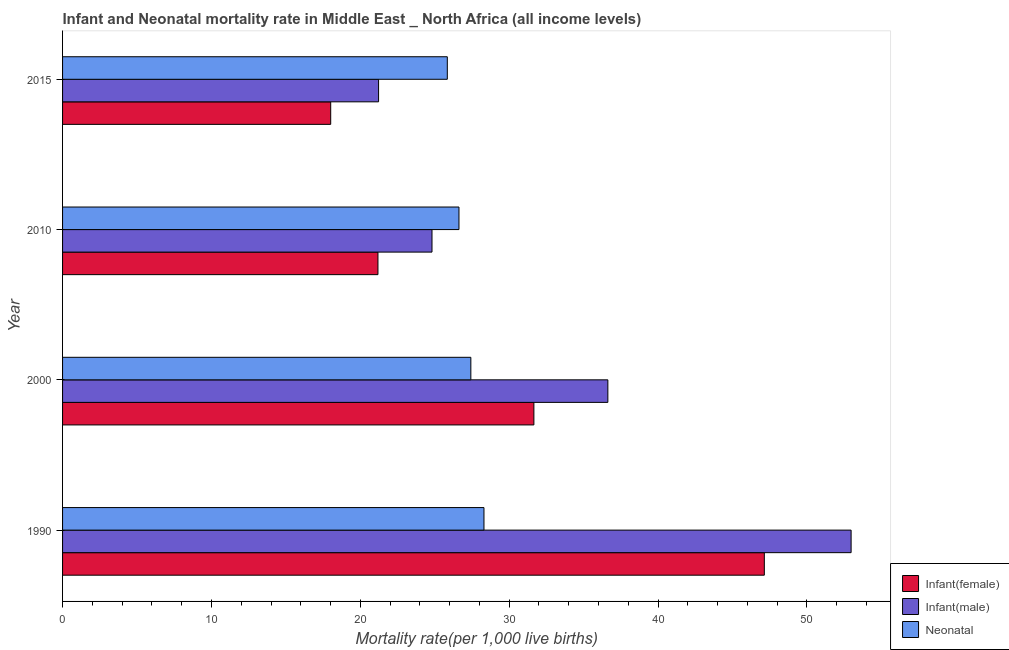How many different coloured bars are there?
Ensure brevity in your answer.  3. Are the number of bars per tick equal to the number of legend labels?
Give a very brief answer. Yes. How many bars are there on the 1st tick from the top?
Your response must be concise. 3. How many bars are there on the 3rd tick from the bottom?
Your response must be concise. 3. What is the label of the 1st group of bars from the top?
Provide a short and direct response. 2015. In how many cases, is the number of bars for a given year not equal to the number of legend labels?
Provide a succinct answer. 0. What is the infant mortality rate(female) in 2010?
Ensure brevity in your answer.  21.18. Across all years, what is the maximum infant mortality rate(male)?
Provide a short and direct response. 52.97. Across all years, what is the minimum infant mortality rate(male)?
Offer a very short reply. 21.23. In which year was the infant mortality rate(female) maximum?
Your answer should be very brief. 1990. In which year was the neonatal mortality rate minimum?
Make the answer very short. 2015. What is the total neonatal mortality rate in the graph?
Offer a very short reply. 108.2. What is the difference between the neonatal mortality rate in 1990 and that in 2015?
Keep it short and to the point. 2.46. What is the difference between the infant mortality rate(male) in 2000 and the infant mortality rate(female) in 2015?
Provide a short and direct response. 18.62. What is the average infant mortality rate(male) per year?
Your response must be concise. 33.91. In the year 1990, what is the difference between the neonatal mortality rate and infant mortality rate(female)?
Make the answer very short. -18.83. In how many years, is the infant mortality rate(female) greater than 10 ?
Offer a very short reply. 4. What is the ratio of the infant mortality rate(female) in 2010 to that in 2015?
Provide a succinct answer. 1.18. Is the difference between the neonatal mortality rate in 1990 and 2000 greater than the difference between the infant mortality rate(male) in 1990 and 2000?
Offer a very short reply. No. What is the difference between the highest and the second highest neonatal mortality rate?
Provide a short and direct response. 0.88. What is the difference between the highest and the lowest neonatal mortality rate?
Your answer should be compact. 2.46. In how many years, is the neonatal mortality rate greater than the average neonatal mortality rate taken over all years?
Your answer should be very brief. 2. What does the 2nd bar from the top in 2000 represents?
Your answer should be compact. Infant(male). What does the 3rd bar from the bottom in 2015 represents?
Provide a short and direct response. Neonatal . Is it the case that in every year, the sum of the infant mortality rate(female) and infant mortality rate(male) is greater than the neonatal mortality rate?
Offer a terse response. Yes. How many bars are there?
Offer a very short reply. 12. Does the graph contain any zero values?
Your response must be concise. No. What is the title of the graph?
Your response must be concise. Infant and Neonatal mortality rate in Middle East _ North Africa (all income levels). What is the label or title of the X-axis?
Your response must be concise. Mortality rate(per 1,0 live births). What is the label or title of the Y-axis?
Offer a very short reply. Year. What is the Mortality rate(per 1,000 live births) of Infant(female) in 1990?
Your response must be concise. 47.14. What is the Mortality rate(per 1,000 live births) in Infant(male) in 1990?
Offer a terse response. 52.97. What is the Mortality rate(per 1,000 live births) in Neonatal  in 1990?
Your answer should be compact. 28.31. What is the Mortality rate(per 1,000 live births) of Infant(female) in 2000?
Give a very brief answer. 31.66. What is the Mortality rate(per 1,000 live births) of Infant(male) in 2000?
Your answer should be compact. 36.63. What is the Mortality rate(per 1,000 live births) in Neonatal  in 2000?
Offer a terse response. 27.42. What is the Mortality rate(per 1,000 live births) in Infant(female) in 2010?
Offer a very short reply. 21.18. What is the Mortality rate(per 1,000 live births) of Infant(male) in 2010?
Your answer should be very brief. 24.81. What is the Mortality rate(per 1,000 live births) of Neonatal  in 2010?
Make the answer very short. 26.63. What is the Mortality rate(per 1,000 live births) in Infant(female) in 2015?
Make the answer very short. 18.01. What is the Mortality rate(per 1,000 live births) of Infant(male) in 2015?
Provide a short and direct response. 21.23. What is the Mortality rate(per 1,000 live births) of Neonatal  in 2015?
Provide a succinct answer. 25.84. Across all years, what is the maximum Mortality rate(per 1,000 live births) of Infant(female)?
Keep it short and to the point. 47.14. Across all years, what is the maximum Mortality rate(per 1,000 live births) of Infant(male)?
Give a very brief answer. 52.97. Across all years, what is the maximum Mortality rate(per 1,000 live births) in Neonatal ?
Provide a succinct answer. 28.31. Across all years, what is the minimum Mortality rate(per 1,000 live births) of Infant(female)?
Give a very brief answer. 18.01. Across all years, what is the minimum Mortality rate(per 1,000 live births) of Infant(male)?
Your answer should be very brief. 21.23. Across all years, what is the minimum Mortality rate(per 1,000 live births) in Neonatal ?
Ensure brevity in your answer.  25.84. What is the total Mortality rate(per 1,000 live births) of Infant(female) in the graph?
Provide a short and direct response. 117.99. What is the total Mortality rate(per 1,000 live births) of Infant(male) in the graph?
Keep it short and to the point. 135.63. What is the total Mortality rate(per 1,000 live births) of Neonatal  in the graph?
Provide a succinct answer. 108.2. What is the difference between the Mortality rate(per 1,000 live births) in Infant(female) in 1990 and that in 2000?
Offer a very short reply. 15.48. What is the difference between the Mortality rate(per 1,000 live births) in Infant(male) in 1990 and that in 2000?
Make the answer very short. 16.34. What is the difference between the Mortality rate(per 1,000 live births) in Neonatal  in 1990 and that in 2000?
Give a very brief answer. 0.88. What is the difference between the Mortality rate(per 1,000 live births) of Infant(female) in 1990 and that in 2010?
Provide a succinct answer. 25.95. What is the difference between the Mortality rate(per 1,000 live births) in Infant(male) in 1990 and that in 2010?
Provide a short and direct response. 28.15. What is the difference between the Mortality rate(per 1,000 live births) in Neonatal  in 1990 and that in 2010?
Provide a short and direct response. 1.68. What is the difference between the Mortality rate(per 1,000 live births) of Infant(female) in 1990 and that in 2015?
Your response must be concise. 29.13. What is the difference between the Mortality rate(per 1,000 live births) in Infant(male) in 1990 and that in 2015?
Offer a terse response. 31.74. What is the difference between the Mortality rate(per 1,000 live births) in Neonatal  in 1990 and that in 2015?
Your answer should be compact. 2.46. What is the difference between the Mortality rate(per 1,000 live births) of Infant(female) in 2000 and that in 2010?
Offer a terse response. 10.47. What is the difference between the Mortality rate(per 1,000 live births) in Infant(male) in 2000 and that in 2010?
Your answer should be compact. 11.81. What is the difference between the Mortality rate(per 1,000 live births) of Neonatal  in 2000 and that in 2010?
Offer a terse response. 0.8. What is the difference between the Mortality rate(per 1,000 live births) of Infant(female) in 2000 and that in 2015?
Keep it short and to the point. 13.65. What is the difference between the Mortality rate(per 1,000 live births) in Infant(male) in 2000 and that in 2015?
Ensure brevity in your answer.  15.4. What is the difference between the Mortality rate(per 1,000 live births) of Neonatal  in 2000 and that in 2015?
Offer a terse response. 1.58. What is the difference between the Mortality rate(per 1,000 live births) in Infant(female) in 2010 and that in 2015?
Offer a very short reply. 3.17. What is the difference between the Mortality rate(per 1,000 live births) in Infant(male) in 2010 and that in 2015?
Provide a short and direct response. 3.59. What is the difference between the Mortality rate(per 1,000 live births) of Neonatal  in 2010 and that in 2015?
Offer a terse response. 0.78. What is the difference between the Mortality rate(per 1,000 live births) in Infant(female) in 1990 and the Mortality rate(per 1,000 live births) in Infant(male) in 2000?
Give a very brief answer. 10.51. What is the difference between the Mortality rate(per 1,000 live births) in Infant(female) in 1990 and the Mortality rate(per 1,000 live births) in Neonatal  in 2000?
Ensure brevity in your answer.  19.71. What is the difference between the Mortality rate(per 1,000 live births) of Infant(male) in 1990 and the Mortality rate(per 1,000 live births) of Neonatal  in 2000?
Keep it short and to the point. 25.54. What is the difference between the Mortality rate(per 1,000 live births) of Infant(female) in 1990 and the Mortality rate(per 1,000 live births) of Infant(male) in 2010?
Ensure brevity in your answer.  22.32. What is the difference between the Mortality rate(per 1,000 live births) in Infant(female) in 1990 and the Mortality rate(per 1,000 live births) in Neonatal  in 2010?
Your answer should be very brief. 20.51. What is the difference between the Mortality rate(per 1,000 live births) of Infant(male) in 1990 and the Mortality rate(per 1,000 live births) of Neonatal  in 2010?
Offer a terse response. 26.34. What is the difference between the Mortality rate(per 1,000 live births) in Infant(female) in 1990 and the Mortality rate(per 1,000 live births) in Infant(male) in 2015?
Your response must be concise. 25.91. What is the difference between the Mortality rate(per 1,000 live births) in Infant(female) in 1990 and the Mortality rate(per 1,000 live births) in Neonatal  in 2015?
Give a very brief answer. 21.29. What is the difference between the Mortality rate(per 1,000 live births) of Infant(male) in 1990 and the Mortality rate(per 1,000 live births) of Neonatal  in 2015?
Ensure brevity in your answer.  27.12. What is the difference between the Mortality rate(per 1,000 live births) of Infant(female) in 2000 and the Mortality rate(per 1,000 live births) of Infant(male) in 2010?
Make the answer very short. 6.84. What is the difference between the Mortality rate(per 1,000 live births) of Infant(female) in 2000 and the Mortality rate(per 1,000 live births) of Neonatal  in 2010?
Provide a short and direct response. 5.03. What is the difference between the Mortality rate(per 1,000 live births) in Infant(male) in 2000 and the Mortality rate(per 1,000 live births) in Neonatal  in 2010?
Ensure brevity in your answer.  10. What is the difference between the Mortality rate(per 1,000 live births) of Infant(female) in 2000 and the Mortality rate(per 1,000 live births) of Infant(male) in 2015?
Make the answer very short. 10.43. What is the difference between the Mortality rate(per 1,000 live births) in Infant(female) in 2000 and the Mortality rate(per 1,000 live births) in Neonatal  in 2015?
Offer a terse response. 5.82. What is the difference between the Mortality rate(per 1,000 live births) of Infant(male) in 2000 and the Mortality rate(per 1,000 live births) of Neonatal  in 2015?
Your answer should be very brief. 10.78. What is the difference between the Mortality rate(per 1,000 live births) of Infant(female) in 2010 and the Mortality rate(per 1,000 live births) of Infant(male) in 2015?
Keep it short and to the point. -0.04. What is the difference between the Mortality rate(per 1,000 live births) in Infant(female) in 2010 and the Mortality rate(per 1,000 live births) in Neonatal  in 2015?
Your answer should be compact. -4.66. What is the difference between the Mortality rate(per 1,000 live births) in Infant(male) in 2010 and the Mortality rate(per 1,000 live births) in Neonatal  in 2015?
Your answer should be compact. -1.03. What is the average Mortality rate(per 1,000 live births) in Infant(female) per year?
Make the answer very short. 29.5. What is the average Mortality rate(per 1,000 live births) of Infant(male) per year?
Your answer should be very brief. 33.91. What is the average Mortality rate(per 1,000 live births) in Neonatal  per year?
Keep it short and to the point. 27.05. In the year 1990, what is the difference between the Mortality rate(per 1,000 live births) in Infant(female) and Mortality rate(per 1,000 live births) in Infant(male)?
Your answer should be very brief. -5.83. In the year 1990, what is the difference between the Mortality rate(per 1,000 live births) in Infant(female) and Mortality rate(per 1,000 live births) in Neonatal ?
Your answer should be compact. 18.83. In the year 1990, what is the difference between the Mortality rate(per 1,000 live births) in Infant(male) and Mortality rate(per 1,000 live births) in Neonatal ?
Provide a short and direct response. 24.66. In the year 2000, what is the difference between the Mortality rate(per 1,000 live births) of Infant(female) and Mortality rate(per 1,000 live births) of Infant(male)?
Provide a short and direct response. -4.97. In the year 2000, what is the difference between the Mortality rate(per 1,000 live births) in Infant(female) and Mortality rate(per 1,000 live births) in Neonatal ?
Offer a terse response. 4.24. In the year 2000, what is the difference between the Mortality rate(per 1,000 live births) of Infant(male) and Mortality rate(per 1,000 live births) of Neonatal ?
Your answer should be compact. 9.2. In the year 2010, what is the difference between the Mortality rate(per 1,000 live births) of Infant(female) and Mortality rate(per 1,000 live births) of Infant(male)?
Ensure brevity in your answer.  -3.63. In the year 2010, what is the difference between the Mortality rate(per 1,000 live births) in Infant(female) and Mortality rate(per 1,000 live births) in Neonatal ?
Keep it short and to the point. -5.44. In the year 2010, what is the difference between the Mortality rate(per 1,000 live births) in Infant(male) and Mortality rate(per 1,000 live births) in Neonatal ?
Keep it short and to the point. -1.81. In the year 2015, what is the difference between the Mortality rate(per 1,000 live births) in Infant(female) and Mortality rate(per 1,000 live births) in Infant(male)?
Give a very brief answer. -3.21. In the year 2015, what is the difference between the Mortality rate(per 1,000 live births) of Infant(female) and Mortality rate(per 1,000 live births) of Neonatal ?
Give a very brief answer. -7.83. In the year 2015, what is the difference between the Mortality rate(per 1,000 live births) in Infant(male) and Mortality rate(per 1,000 live births) in Neonatal ?
Offer a terse response. -4.62. What is the ratio of the Mortality rate(per 1,000 live births) in Infant(female) in 1990 to that in 2000?
Provide a succinct answer. 1.49. What is the ratio of the Mortality rate(per 1,000 live births) in Infant(male) in 1990 to that in 2000?
Your answer should be very brief. 1.45. What is the ratio of the Mortality rate(per 1,000 live births) of Neonatal  in 1990 to that in 2000?
Ensure brevity in your answer.  1.03. What is the ratio of the Mortality rate(per 1,000 live births) of Infant(female) in 1990 to that in 2010?
Your answer should be very brief. 2.23. What is the ratio of the Mortality rate(per 1,000 live births) in Infant(male) in 1990 to that in 2010?
Provide a succinct answer. 2.13. What is the ratio of the Mortality rate(per 1,000 live births) in Neonatal  in 1990 to that in 2010?
Provide a short and direct response. 1.06. What is the ratio of the Mortality rate(per 1,000 live births) in Infant(female) in 1990 to that in 2015?
Make the answer very short. 2.62. What is the ratio of the Mortality rate(per 1,000 live births) of Infant(male) in 1990 to that in 2015?
Keep it short and to the point. 2.5. What is the ratio of the Mortality rate(per 1,000 live births) of Neonatal  in 1990 to that in 2015?
Provide a short and direct response. 1.1. What is the ratio of the Mortality rate(per 1,000 live births) of Infant(female) in 2000 to that in 2010?
Your answer should be compact. 1.49. What is the ratio of the Mortality rate(per 1,000 live births) in Infant(male) in 2000 to that in 2010?
Give a very brief answer. 1.48. What is the ratio of the Mortality rate(per 1,000 live births) in Infant(female) in 2000 to that in 2015?
Your answer should be very brief. 1.76. What is the ratio of the Mortality rate(per 1,000 live births) in Infant(male) in 2000 to that in 2015?
Ensure brevity in your answer.  1.73. What is the ratio of the Mortality rate(per 1,000 live births) of Neonatal  in 2000 to that in 2015?
Ensure brevity in your answer.  1.06. What is the ratio of the Mortality rate(per 1,000 live births) in Infant(female) in 2010 to that in 2015?
Ensure brevity in your answer.  1.18. What is the ratio of the Mortality rate(per 1,000 live births) of Infant(male) in 2010 to that in 2015?
Your answer should be compact. 1.17. What is the ratio of the Mortality rate(per 1,000 live births) of Neonatal  in 2010 to that in 2015?
Ensure brevity in your answer.  1.03. What is the difference between the highest and the second highest Mortality rate(per 1,000 live births) in Infant(female)?
Your response must be concise. 15.48. What is the difference between the highest and the second highest Mortality rate(per 1,000 live births) of Infant(male)?
Your answer should be compact. 16.34. What is the difference between the highest and the second highest Mortality rate(per 1,000 live births) of Neonatal ?
Make the answer very short. 0.88. What is the difference between the highest and the lowest Mortality rate(per 1,000 live births) of Infant(female)?
Ensure brevity in your answer.  29.13. What is the difference between the highest and the lowest Mortality rate(per 1,000 live births) of Infant(male)?
Offer a very short reply. 31.74. What is the difference between the highest and the lowest Mortality rate(per 1,000 live births) of Neonatal ?
Your answer should be compact. 2.46. 